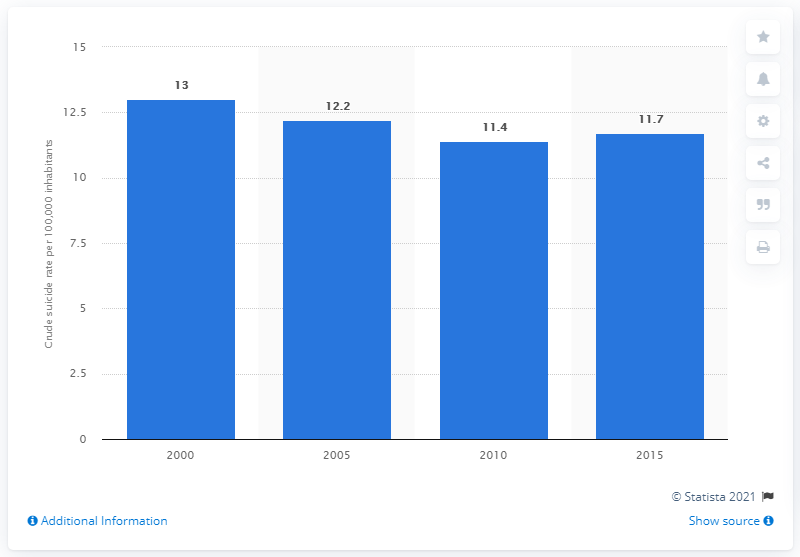List a handful of essential elements in this visual. In 2015, the crude suicide rate in Bhutan was 11.7 per 100,000 individuals. 